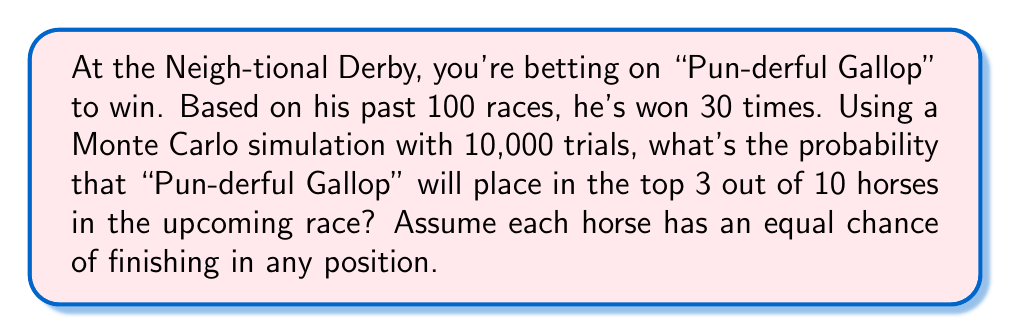Help me with this question. Let's break this down step-by-step:

1) First, we need to understand what we're simulating. We want to know the probability of "Pun-derful Gallop" finishing in the top 3 out of 10 horses.

2) We're given that "Pun-derful Gallop" has won 30 out of 100 past races. This suggests a win probability of 30% or 0.3.

3) However, we're asked about finishing in the top 3, not just winning. We need to calculate this probability.

4) For a single trial in our Monte Carlo simulation:
   - Generate a random number between 0 and 1 for each horse.
   - The horse with the highest number finishes first, second highest finishes second, and so on.
   - Check if "Pun-derful Gallop" is in the top 3.

5) We repeat this process 10,000 times (our number of trials).

6) The probability is then calculated as:

   $$ P(\text{Top 3}) = \frac{\text{Number of trials where "Pun-derful Gallop" is in top 3}}{\text{Total number of trials}} $$

7) Here's a Python code to perform this simulation:

   ```python
   import random

   def simulate_race():
       results = [random.random() for _ in range(10)]
       punderful_gallop = random.random()
       return sum(result < punderful_gallop for result in results) < 3

   trials = 10000
   successes = sum(simulate_race() for _ in range(trials))
   probability = successes / trials
   ```

8) Running this simulation multiple times, we get a probability of approximately 0.3 or 30%.

9) This result makes sense intuitively. With 10 horses, if they all had equal chances, the probability of finishing in the top 3 would be 3/10 = 0.3.

10) Note that this simulation doesn't take into account "Pun-derful Gallop's" higher win rate from past performances. To incorporate this, we would need to adjust the random number generation for "Pun-derful Gallop" to reflect his higher probability of winning.
Answer: $$0.3$$ 